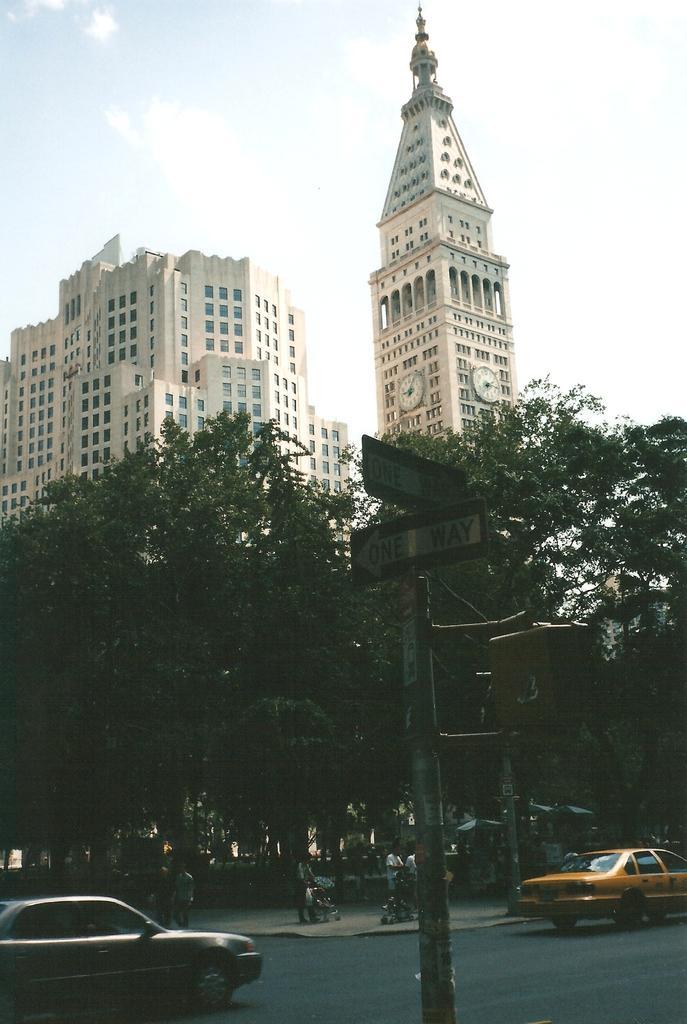Can you describe this image briefly? In this image there is a road at the bottom. On the road there are two cars. There are trees on the footpath. Behind the trees there are tall buildings. There is a wall clock to the building. At the top there is the sky. In the middle there is a directional board. 